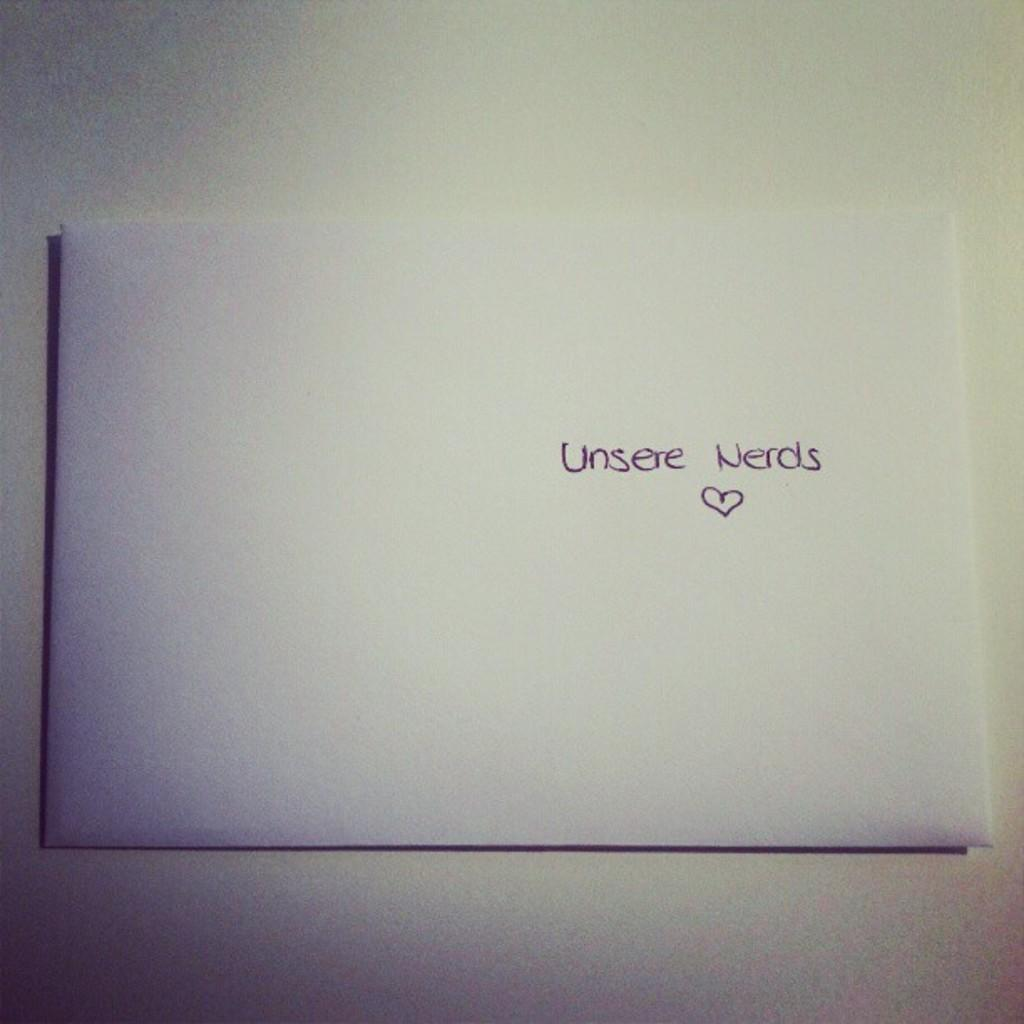Provide a one-sentence caption for the provided image. An envelope with the words "Unsere Nerds" and a heart. 